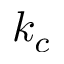Convert formula to latex. <formula><loc_0><loc_0><loc_500><loc_500>k _ { c }</formula> 